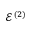Convert formula to latex. <formula><loc_0><loc_0><loc_500><loc_500>\mathcal { E } ^ { ( 2 ) }</formula> 